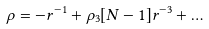<formula> <loc_0><loc_0><loc_500><loc_500>\rho = - r ^ { - 1 } + \rho _ { 3 } [ N - 1 ] r ^ { - 3 } + \dots</formula> 